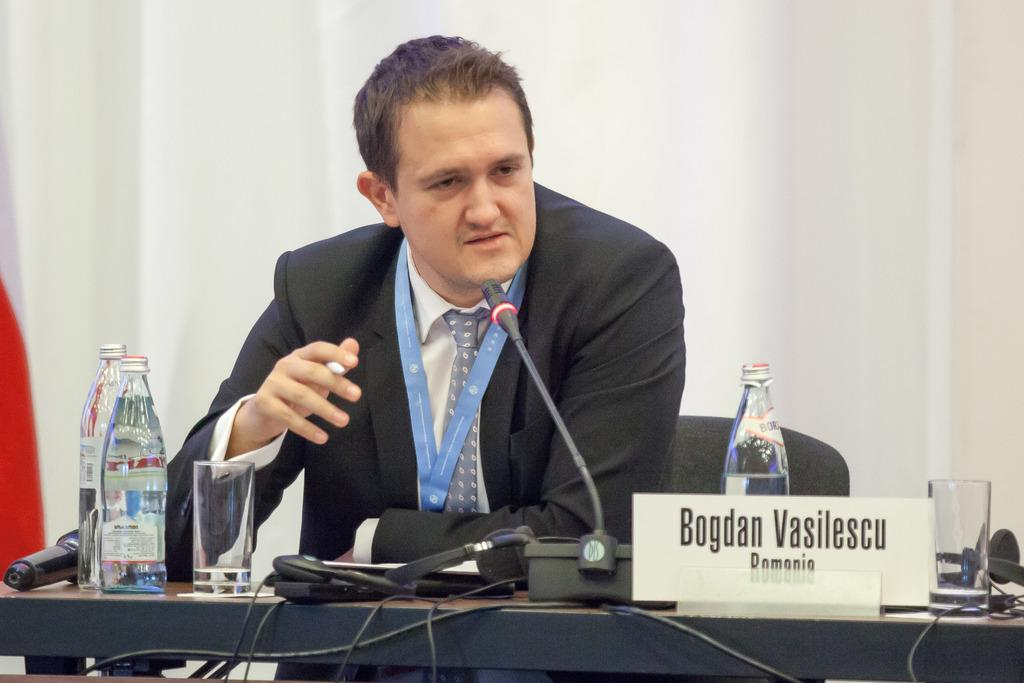What is the person in the image doing? The person is sitting and talking into a microphone. What objects can be seen on the table in the image? The specific objects on the table are not mentioned, but there are objects present. What additional detail can be observed about the person in the image? There is a name plate in the image. How many waves can be seen crashing on the shore in the image? There are no waves present in the image; it features a person sitting and talking into a microphone. 